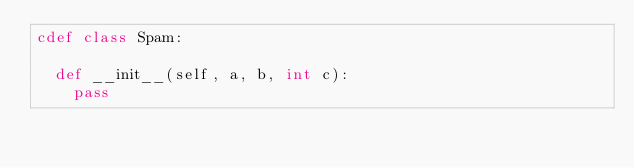<code> <loc_0><loc_0><loc_500><loc_500><_Cython_>cdef class Spam:

	def __init__(self, a, b, int c):
		pass
</code> 